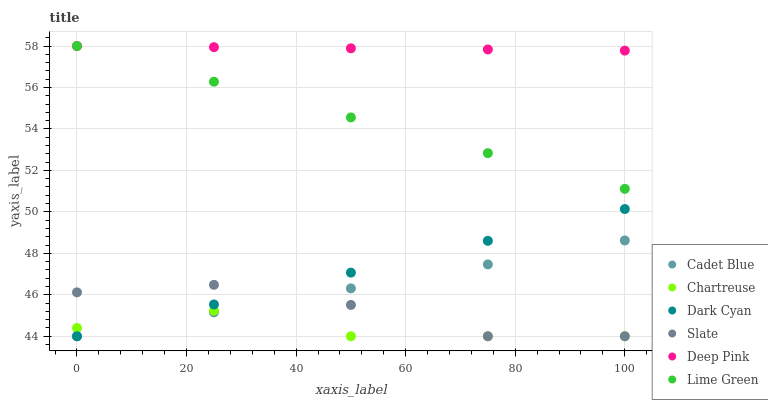Does Chartreuse have the minimum area under the curve?
Answer yes or no. Yes. Does Deep Pink have the maximum area under the curve?
Answer yes or no. Yes. Does Slate have the minimum area under the curve?
Answer yes or no. No. Does Slate have the maximum area under the curve?
Answer yes or no. No. Is Cadet Blue the smoothest?
Answer yes or no. Yes. Is Slate the roughest?
Answer yes or no. Yes. Is Chartreuse the smoothest?
Answer yes or no. No. Is Chartreuse the roughest?
Answer yes or no. No. Does Cadet Blue have the lowest value?
Answer yes or no. Yes. Does Deep Pink have the lowest value?
Answer yes or no. No. Does Lime Green have the highest value?
Answer yes or no. Yes. Does Slate have the highest value?
Answer yes or no. No. Is Dark Cyan less than Lime Green?
Answer yes or no. Yes. Is Deep Pink greater than Dark Cyan?
Answer yes or no. Yes. Does Dark Cyan intersect Slate?
Answer yes or no. Yes. Is Dark Cyan less than Slate?
Answer yes or no. No. Is Dark Cyan greater than Slate?
Answer yes or no. No. Does Dark Cyan intersect Lime Green?
Answer yes or no. No. 